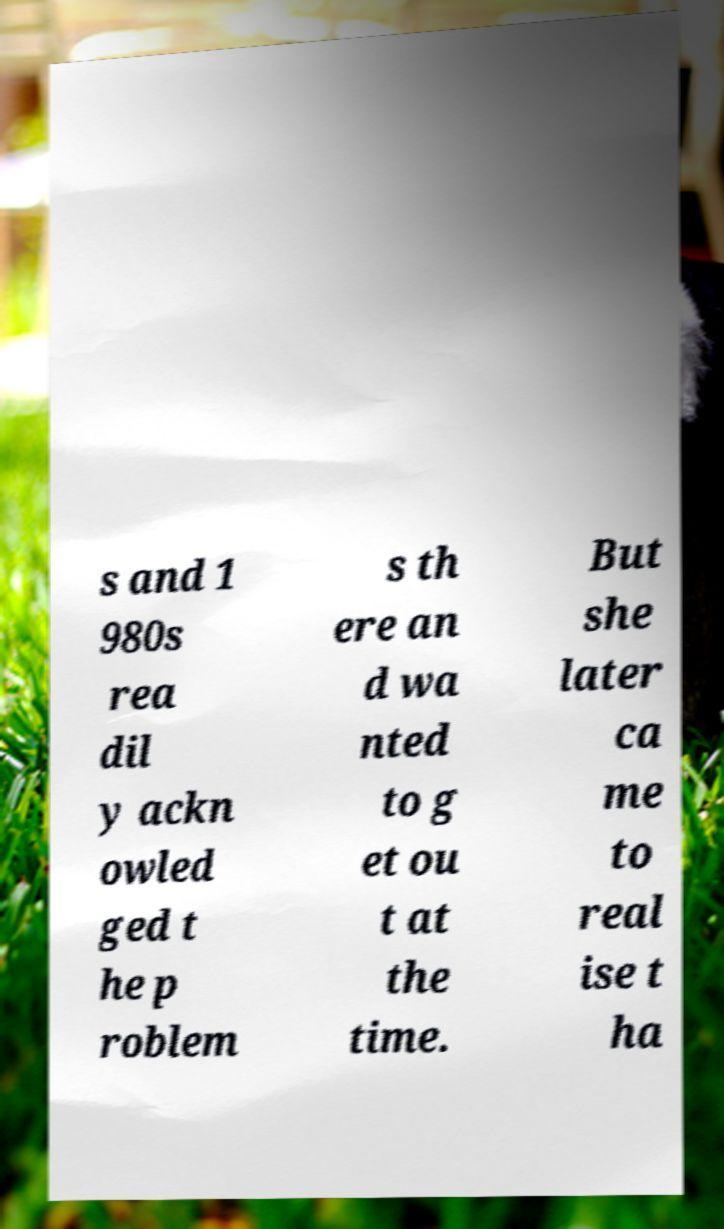Can you read and provide the text displayed in the image?This photo seems to have some interesting text. Can you extract and type it out for me? s and 1 980s rea dil y ackn owled ged t he p roblem s th ere an d wa nted to g et ou t at the time. But she later ca me to real ise t ha 